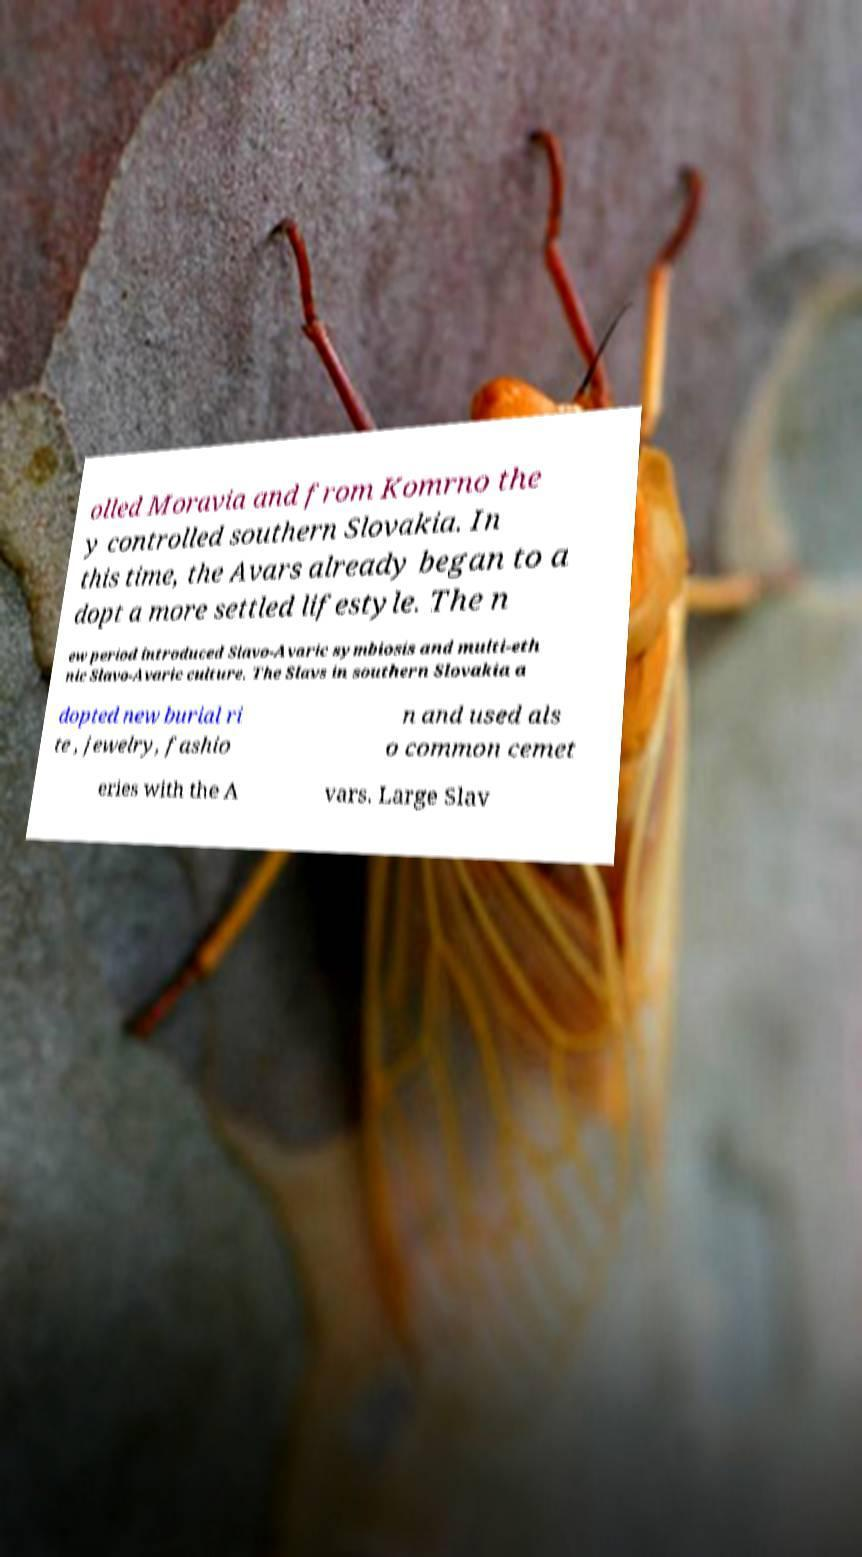Please identify and transcribe the text found in this image. olled Moravia and from Komrno the y controlled southern Slovakia. In this time, the Avars already began to a dopt a more settled lifestyle. The n ew period introduced Slavo-Avaric symbiosis and multi-eth nic Slavo-Avaric culture. The Slavs in southern Slovakia a dopted new burial ri te , jewelry, fashio n and used als o common cemet eries with the A vars. Large Slav 